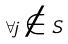Convert formula to latex. <formula><loc_0><loc_0><loc_500><loc_500>\forall j \notin S</formula> 